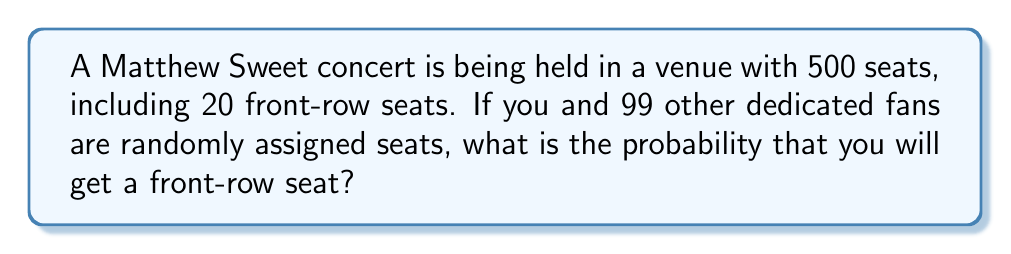Can you answer this question? To solve this problem, we need to use the concept of probability and combinations. Let's break it down step-by-step:

1) First, we need to calculate the total number of ways 100 people can be seated in 500 seats. This is given by the combination formula:

   $$\binom{500}{100} = \frac{500!}{100!(500-100)!} = \frac{500!}{100!400!}$$

2) Next, we need to calculate the number of ways you can get a front-row seat. This can happen in two ways:
   a) You get one of the 20 front-row seats, and the other 99 people are seated in the remaining 480 seats.
   b) You get one of the 480 non-front-row seats, and exactly 20 of the other 99 people get the front-row seats.

3) For scenario (a), there are 20 ways for you to get a front-row seat, and then:

   $$\binom{480}{99}$$ 

   ways for the others to be seated.

4) For scenario (b), there are 480 ways for you to get a non-front-row seat, then:

   $$\binom{99}{20}$$ 

   ways for 20 of the 99 others to get front-row seats, and the remaining 79 to be in the other 460 seats.

5) The total number of favorable outcomes is thus:

   $$20 \cdot \binom{480}{99} + 480 \cdot \binom{99}{20} \cdot \binom{460}{79}$$

6) The probability is then:

   $$P(\text{front-row seat}) = \frac{20 \cdot \binom{480}{99} + 480 \cdot \binom{99}{20} \cdot \binom{460}{79}}{\binom{500}{100}}$$

7) Calculating this (which would typically be done with a computer due to the large numbers involved) gives us the final answer.
Answer: $P(\text{front-row seat}) \approx 0.04$ or 4% 